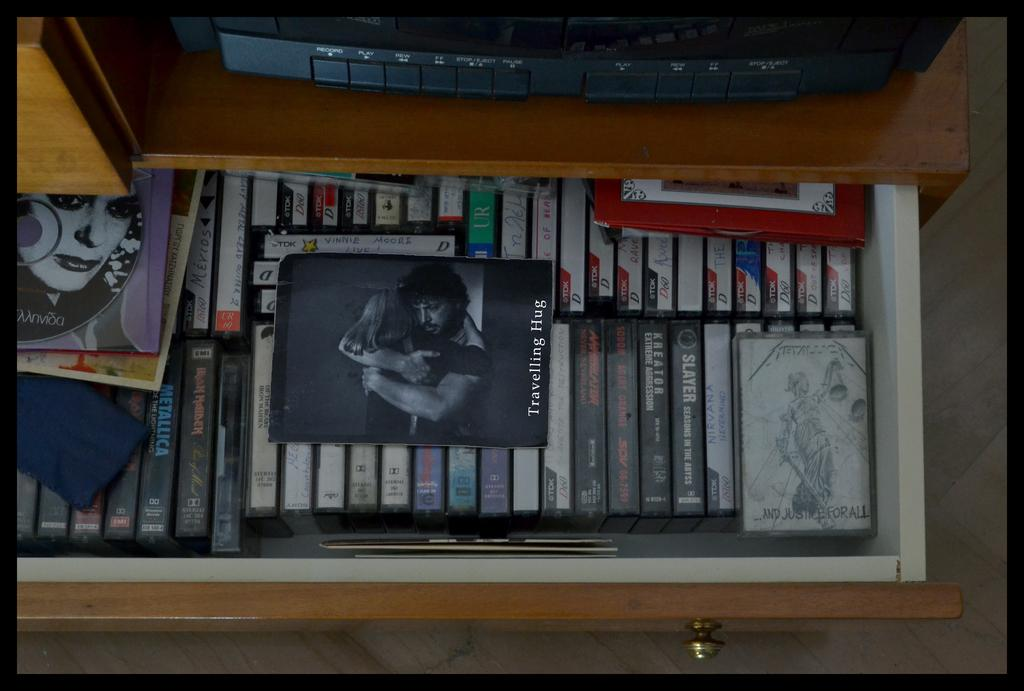<image>
Share a concise interpretation of the image provided. A collection of casette tapes includes one from Slayer. 